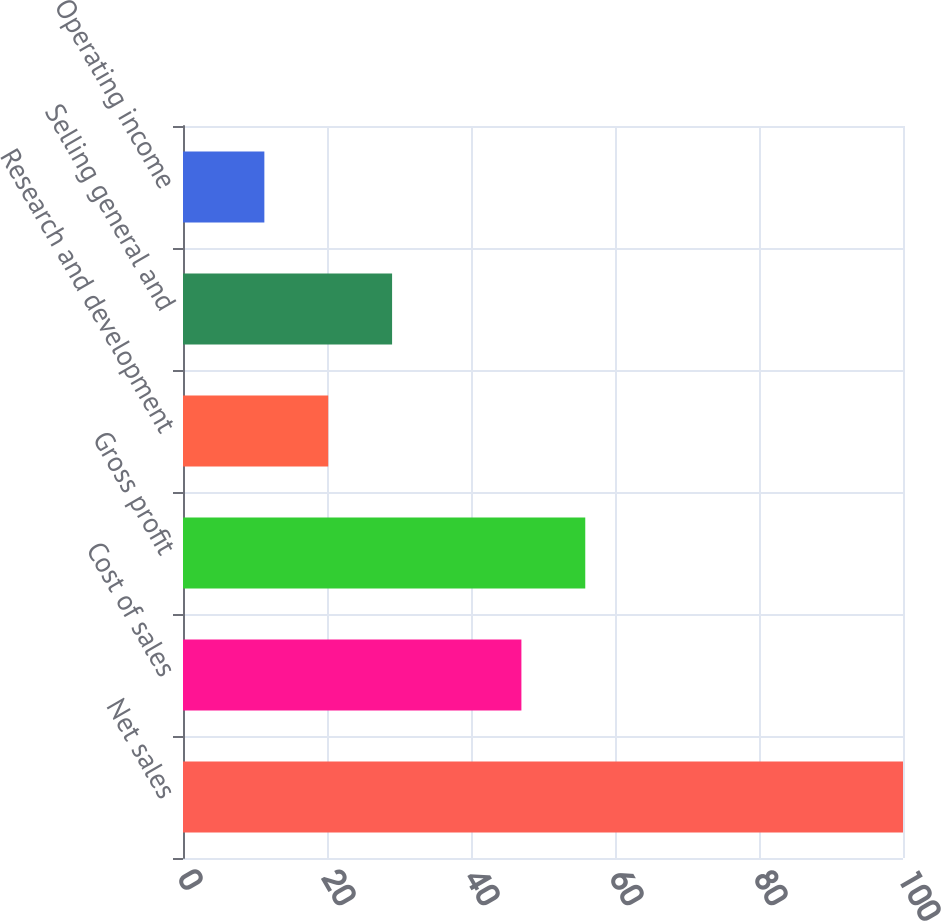Convert chart. <chart><loc_0><loc_0><loc_500><loc_500><bar_chart><fcel>Net sales<fcel>Cost of sales<fcel>Gross profit<fcel>Research and development<fcel>Selling general and<fcel>Operating income<nl><fcel>100<fcel>47<fcel>55.87<fcel>20.17<fcel>29.04<fcel>11.3<nl></chart> 